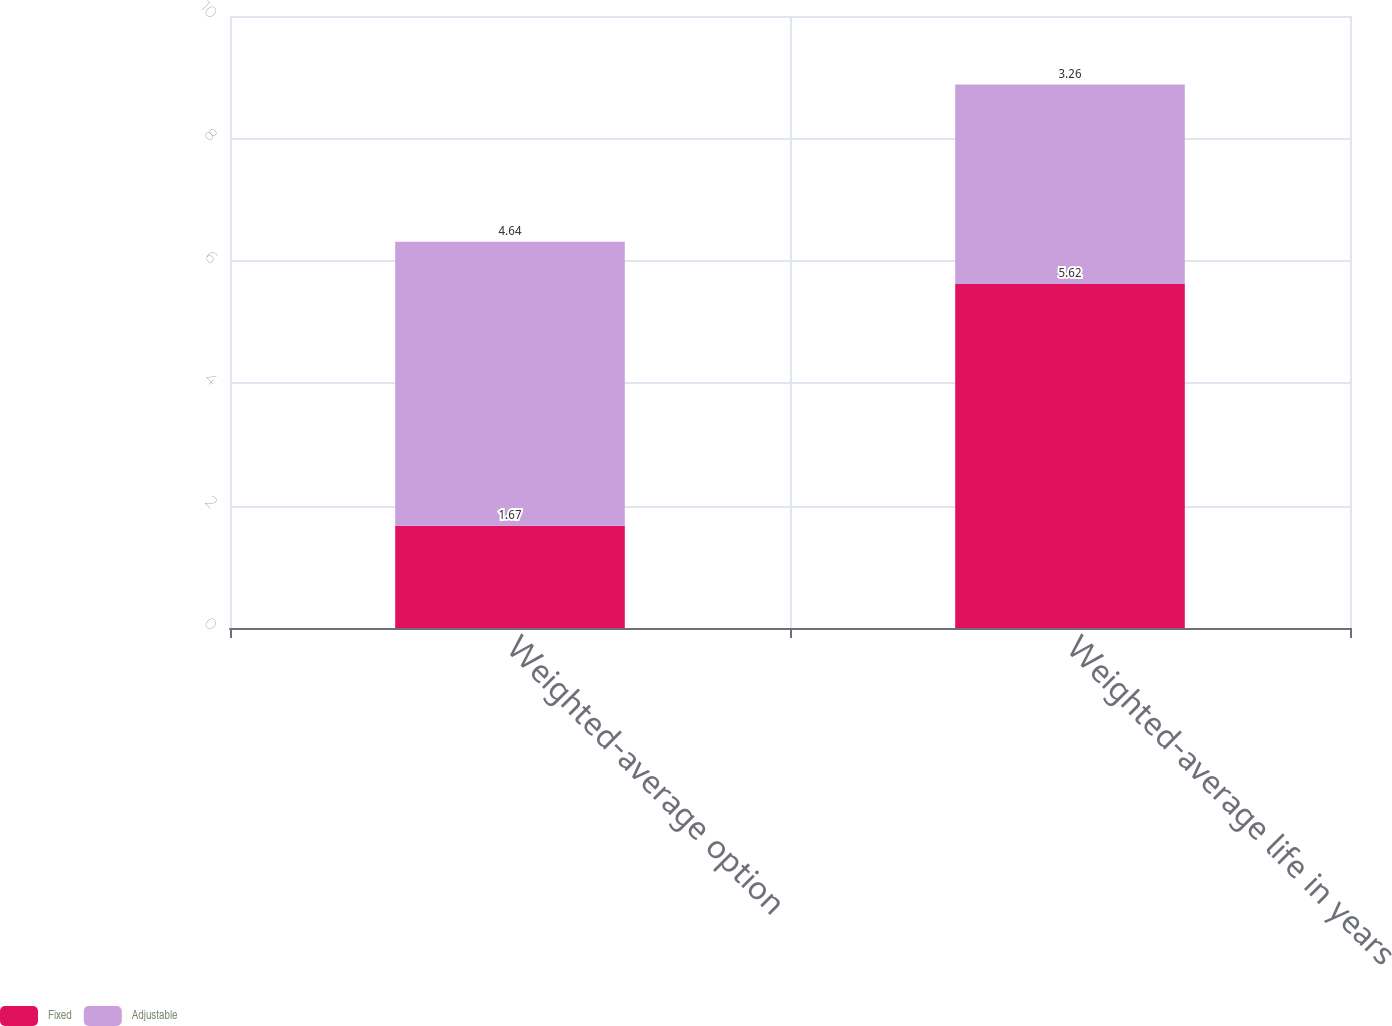Convert chart to OTSL. <chart><loc_0><loc_0><loc_500><loc_500><stacked_bar_chart><ecel><fcel>Weighted-average option<fcel>Weighted-average life in years<nl><fcel>Fixed<fcel>1.67<fcel>5.62<nl><fcel>Adjustable<fcel>4.64<fcel>3.26<nl></chart> 